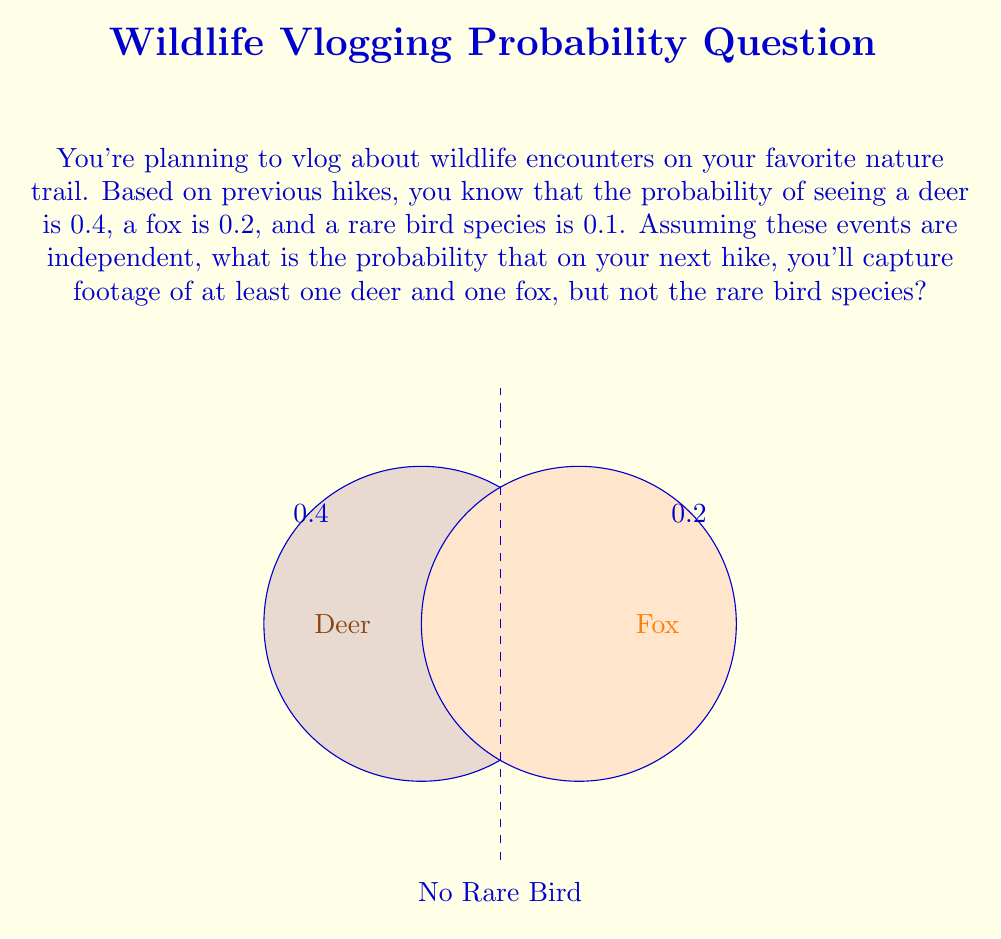Can you answer this question? Let's approach this step-by-step:

1) First, we need to calculate the probability of seeing at least one deer AND at least one fox:
   $P(\text{Deer and Fox}) = P(\text{Deer}) \times P(\text{Fox}) = 0.4 \times 0.2 = 0.08$

2) Now, we need to calculate the probability of NOT seeing the rare bird:
   $P(\text{No Rare Bird}) = 1 - P(\text{Rare Bird}) = 1 - 0.1 = 0.9$

3) Since we want the probability of seeing at least one deer AND one fox AND NOT seeing the rare bird, and these events are independent, we multiply these probabilities:

   $$P(\text{Deer and Fox and No Rare Bird}) = P(\text{Deer and Fox}) \times P(\text{No Rare Bird})$$
   $$= 0.08 \times 0.9 = 0.072$$

4) Therefore, the probability of capturing footage of at least one deer and one fox, but not the rare bird species, is 0.072 or 7.2%.
Answer: 0.072 